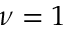Convert formula to latex. <formula><loc_0><loc_0><loc_500><loc_500>\nu = 1</formula> 